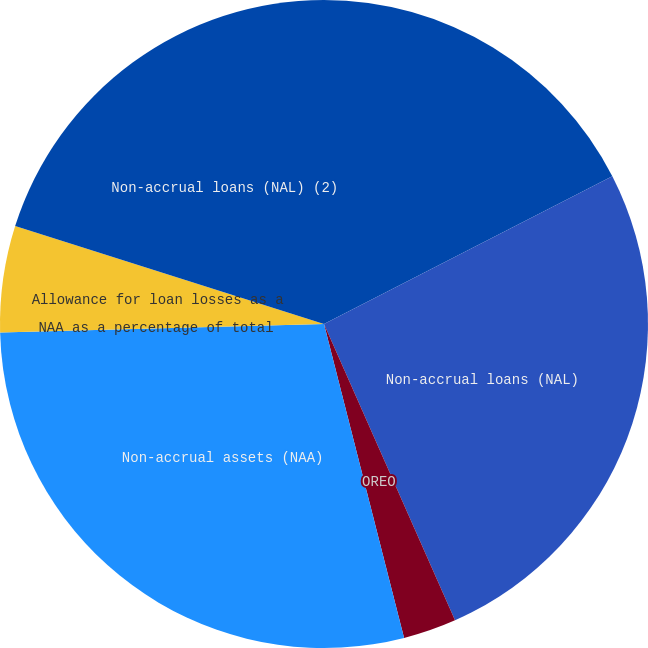<chart> <loc_0><loc_0><loc_500><loc_500><pie_chart><fcel>Non-accrual assets-Total<fcel>Non-accrual loans (NAL)<fcel>OREO<fcel>Non-accrual assets (NAA)<fcel>NAA as a percentage of total<fcel>Allowance for loan losses as a<fcel>Non-accrual loans (NAL) (2)<nl><fcel>17.46%<fcel>25.91%<fcel>2.65%<fcel>28.56%<fcel>0.0%<fcel>5.3%<fcel>20.11%<nl></chart> 